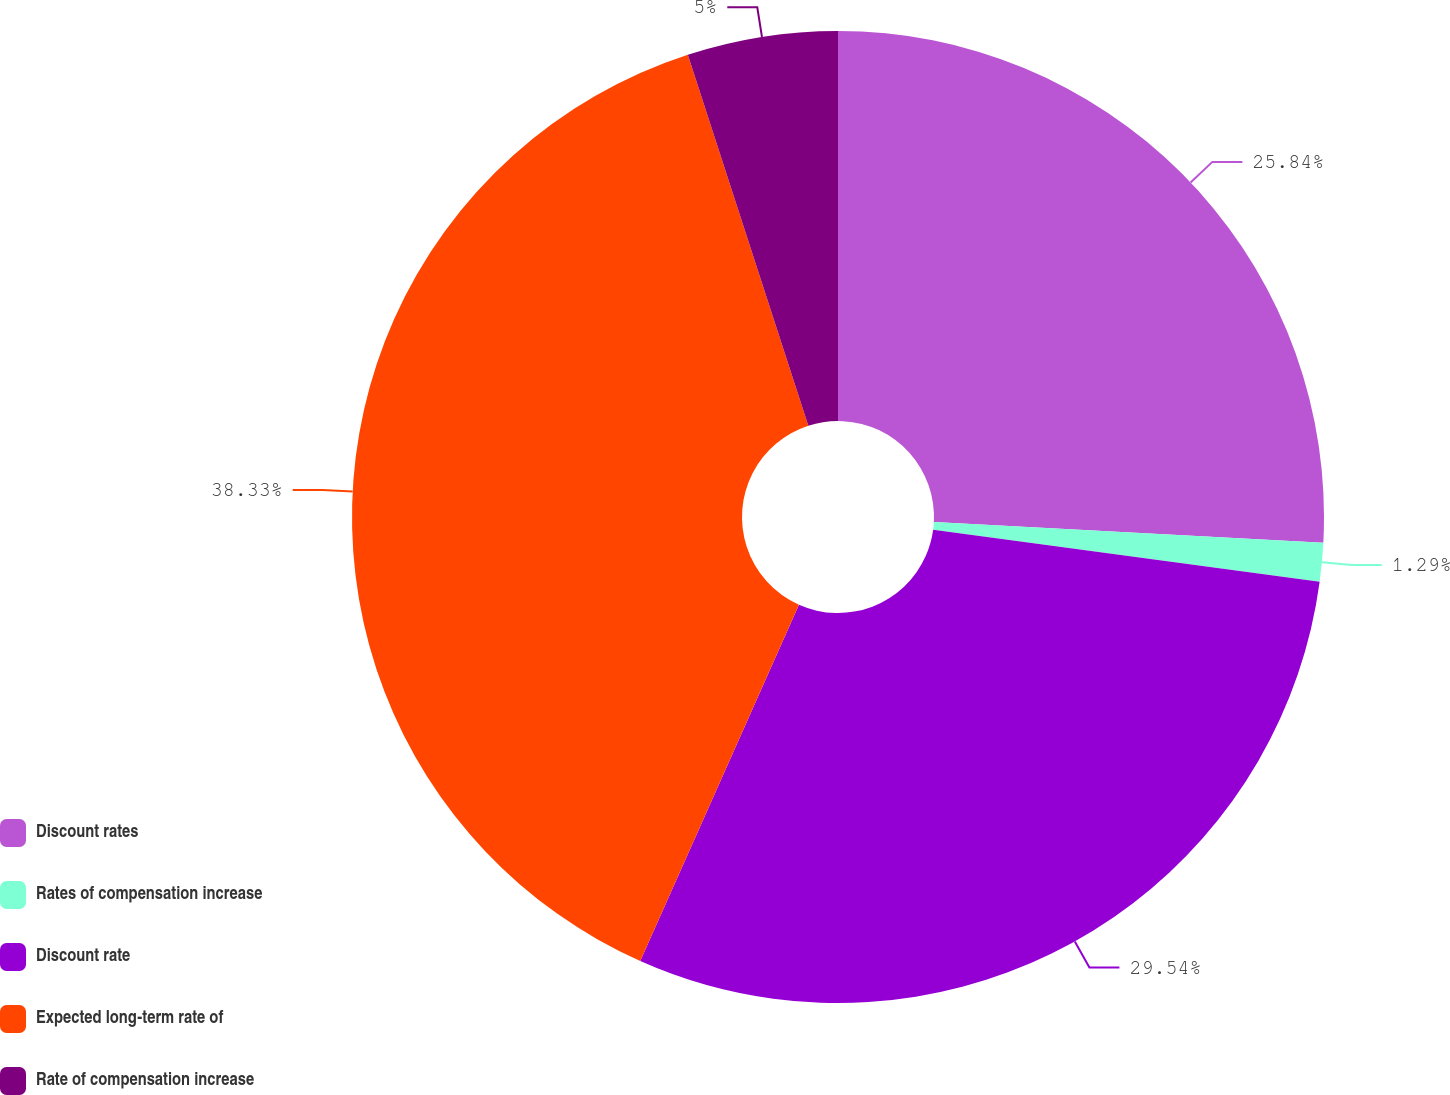Convert chart to OTSL. <chart><loc_0><loc_0><loc_500><loc_500><pie_chart><fcel>Discount rates<fcel>Rates of compensation increase<fcel>Discount rate<fcel>Expected long-term rate of<fcel>Rate of compensation increase<nl><fcel>25.84%<fcel>1.29%<fcel>29.54%<fcel>38.33%<fcel>5.0%<nl></chart> 